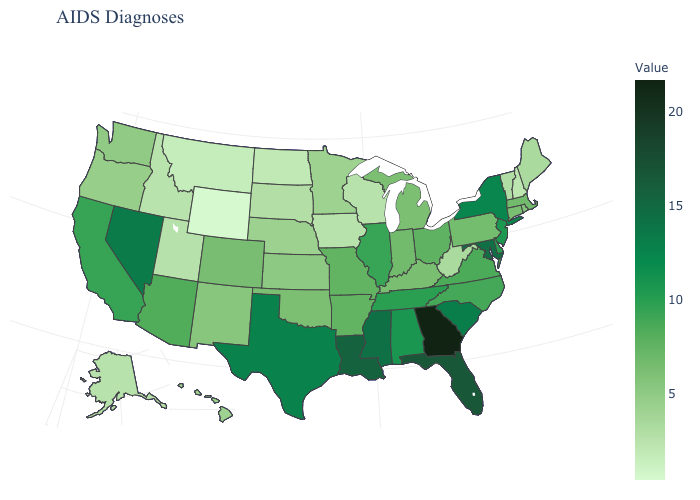Among the states that border New Jersey , which have the lowest value?
Be succinct. Pennsylvania. Which states have the lowest value in the USA?
Answer briefly. Wyoming. Does Montana have the highest value in the West?
Quick response, please. No. Which states hav the highest value in the South?
Concise answer only. Georgia. 